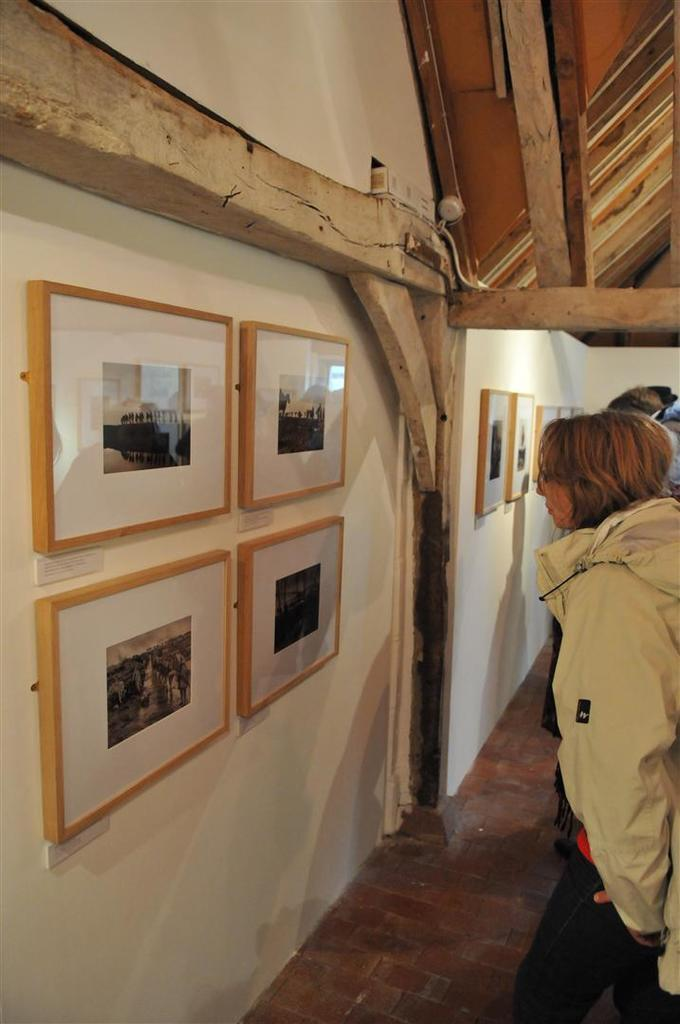What can be seen on the right side of the image? There are people standing on the right side of the image. What is present on the left side of the image? There are photo frames on the walls on the left side of the image. What type of dinosaurs can be seen in the image? There are no dinosaurs present in the image. Are the people in the image reading any books or documents? The provided facts do not mention any books or documents, so it cannot be determined if the people are reading. 